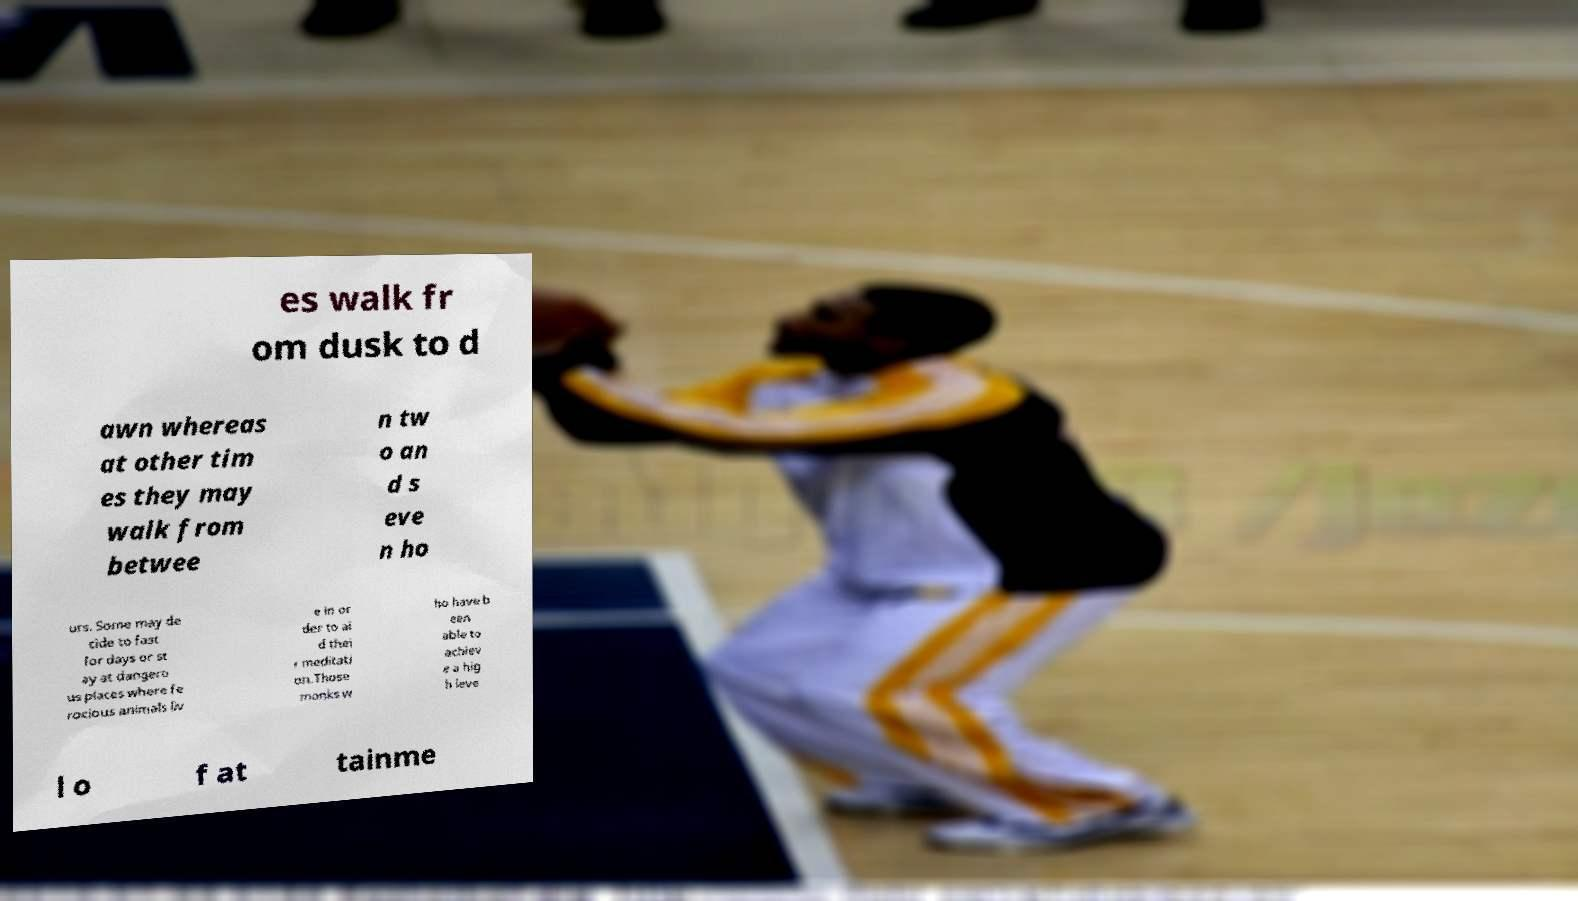What messages or text are displayed in this image? I need them in a readable, typed format. es walk fr om dusk to d awn whereas at other tim es they may walk from betwee n tw o an d s eve n ho urs. Some may de cide to fast for days or st ay at dangero us places where fe rocious animals liv e in or der to ai d thei r meditati on.Those monks w ho have b een able to achiev e a hig h leve l o f at tainme 